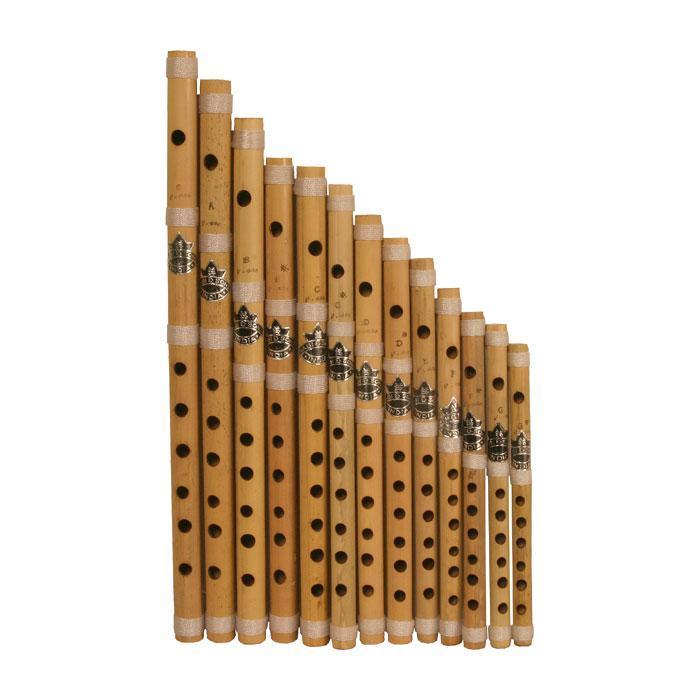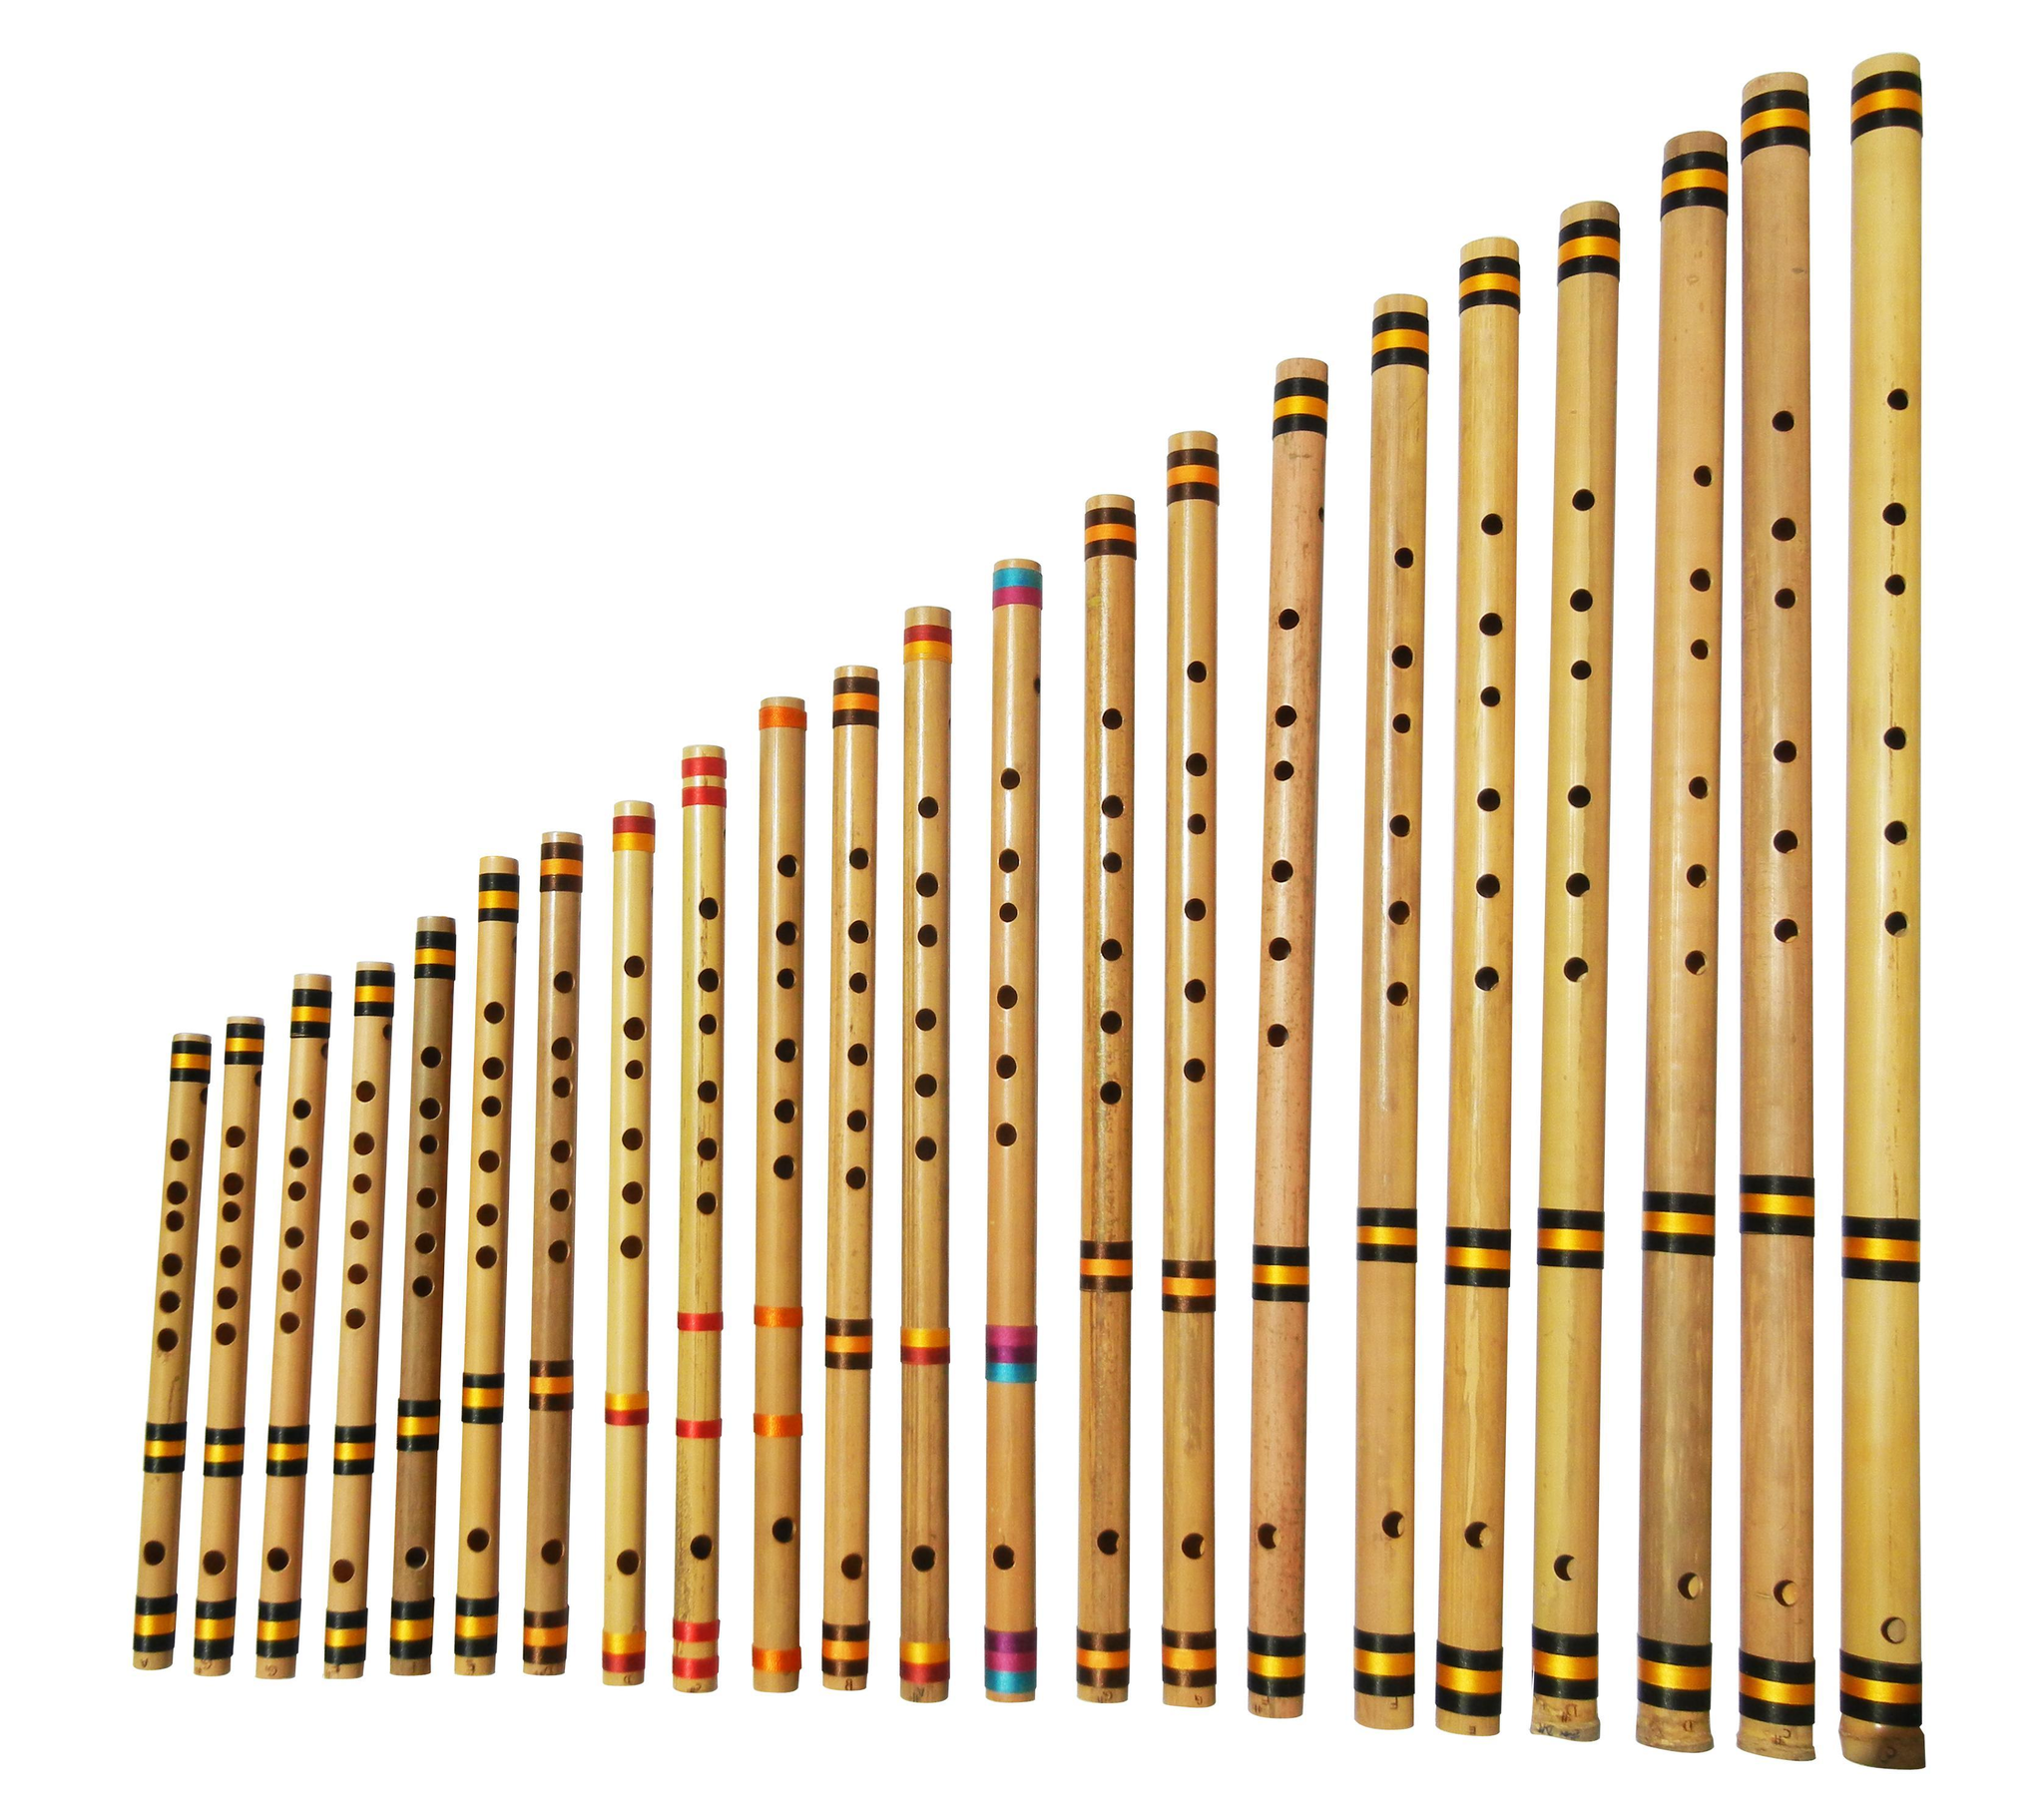The first image is the image on the left, the second image is the image on the right. For the images shown, is this caption "At least 10 flutes are placed sided by side in each picture." true? Answer yes or no. Yes. The first image is the image on the left, the second image is the image on the right. For the images shown, is this caption "The right image shows a row of flutes with red stripes arranged in size order, with one end aligned." true? Answer yes or no. No. 